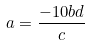<formula> <loc_0><loc_0><loc_500><loc_500>a = \frac { - 1 0 b d } { c }</formula> 